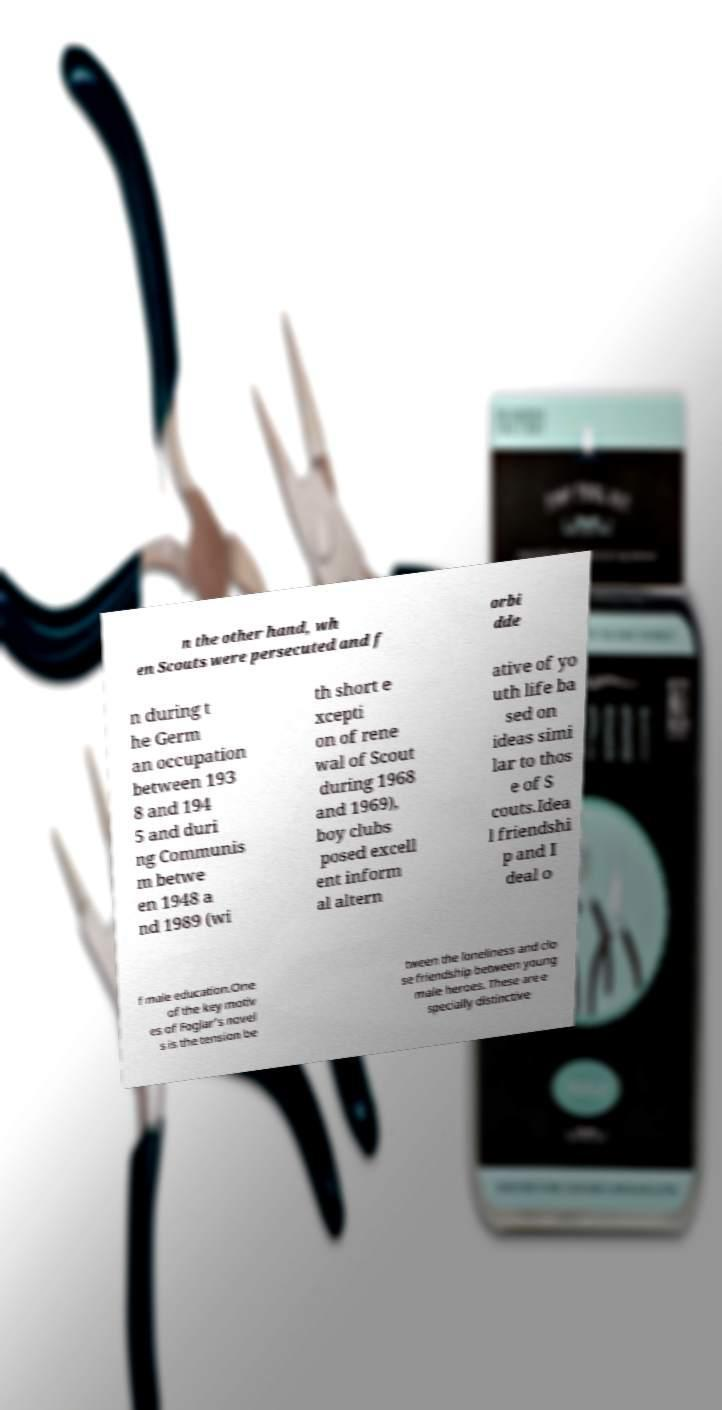I need the written content from this picture converted into text. Can you do that? n the other hand, wh en Scouts were persecuted and f orbi dde n during t he Germ an occupation between 193 8 and 194 5 and duri ng Communis m betwe en 1948 a nd 1989 (wi th short e xcepti on of rene wal of Scout during 1968 and 1969), boy clubs posed excell ent inform al altern ative of yo uth life ba sed on ideas simi lar to thos e of S couts.Idea l friendshi p and I deal o f male education.One of the key motiv es of Foglar's novel s is the tension be tween the loneliness and clo se friendship between young male heroes. These are e specially distinctive 